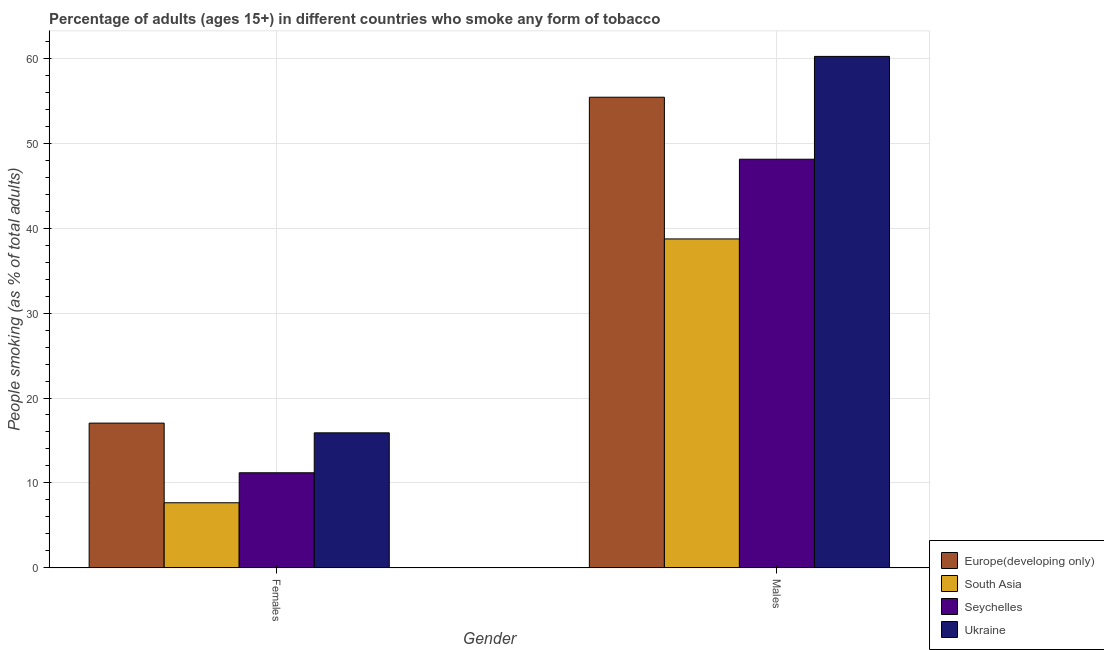How many different coloured bars are there?
Offer a very short reply. 4. How many bars are there on the 2nd tick from the right?
Your response must be concise. 4. What is the label of the 2nd group of bars from the left?
Ensure brevity in your answer.  Males. What is the percentage of females who smoke in Europe(developing only)?
Provide a succinct answer. 17.04. Across all countries, what is the maximum percentage of males who smoke?
Offer a terse response. 60.2. Across all countries, what is the minimum percentage of females who smoke?
Your response must be concise. 7.67. In which country was the percentage of females who smoke maximum?
Your answer should be compact. Europe(developing only). What is the total percentage of males who smoke in the graph?
Offer a terse response. 202.42. What is the difference between the percentage of males who smoke in South Asia and that in Ukraine?
Make the answer very short. -21.48. What is the difference between the percentage of females who smoke in Ukraine and the percentage of males who smoke in South Asia?
Offer a terse response. -22.82. What is the average percentage of males who smoke per country?
Your answer should be compact. 50.6. What is the difference between the percentage of females who smoke and percentage of males who smoke in Seychelles?
Your answer should be very brief. -36.9. What is the ratio of the percentage of males who smoke in Europe(developing only) to that in Ukraine?
Make the answer very short. 0.92. Is the percentage of males who smoke in Europe(developing only) less than that in Ukraine?
Your answer should be compact. Yes. What does the 2nd bar from the left in Females represents?
Give a very brief answer. South Asia. What does the 3rd bar from the right in Males represents?
Make the answer very short. South Asia. Are the values on the major ticks of Y-axis written in scientific E-notation?
Provide a short and direct response. No. Does the graph contain any zero values?
Your response must be concise. No. Does the graph contain grids?
Your answer should be compact. Yes. How are the legend labels stacked?
Provide a succinct answer. Vertical. What is the title of the graph?
Provide a succinct answer. Percentage of adults (ages 15+) in different countries who smoke any form of tobacco. What is the label or title of the Y-axis?
Your response must be concise. People smoking (as % of total adults). What is the People smoking (as % of total adults) of Europe(developing only) in Females?
Offer a terse response. 17.04. What is the People smoking (as % of total adults) of South Asia in Females?
Keep it short and to the point. 7.67. What is the People smoking (as % of total adults) of Seychelles in Females?
Make the answer very short. 11.2. What is the People smoking (as % of total adults) in Europe(developing only) in Males?
Provide a succinct answer. 55.4. What is the People smoking (as % of total adults) of South Asia in Males?
Your response must be concise. 38.72. What is the People smoking (as % of total adults) of Seychelles in Males?
Your answer should be compact. 48.1. What is the People smoking (as % of total adults) of Ukraine in Males?
Your response must be concise. 60.2. Across all Gender, what is the maximum People smoking (as % of total adults) in Europe(developing only)?
Your response must be concise. 55.4. Across all Gender, what is the maximum People smoking (as % of total adults) in South Asia?
Offer a terse response. 38.72. Across all Gender, what is the maximum People smoking (as % of total adults) in Seychelles?
Ensure brevity in your answer.  48.1. Across all Gender, what is the maximum People smoking (as % of total adults) in Ukraine?
Offer a very short reply. 60.2. Across all Gender, what is the minimum People smoking (as % of total adults) in Europe(developing only)?
Provide a succinct answer. 17.04. Across all Gender, what is the minimum People smoking (as % of total adults) in South Asia?
Offer a very short reply. 7.67. Across all Gender, what is the minimum People smoking (as % of total adults) of Ukraine?
Provide a short and direct response. 15.9. What is the total People smoking (as % of total adults) of Europe(developing only) in the graph?
Provide a short and direct response. 72.44. What is the total People smoking (as % of total adults) in South Asia in the graph?
Ensure brevity in your answer.  46.39. What is the total People smoking (as % of total adults) of Seychelles in the graph?
Your answer should be compact. 59.3. What is the total People smoking (as % of total adults) in Ukraine in the graph?
Make the answer very short. 76.1. What is the difference between the People smoking (as % of total adults) of Europe(developing only) in Females and that in Males?
Your response must be concise. -38.35. What is the difference between the People smoking (as % of total adults) of South Asia in Females and that in Males?
Your answer should be very brief. -31.05. What is the difference between the People smoking (as % of total adults) of Seychelles in Females and that in Males?
Ensure brevity in your answer.  -36.9. What is the difference between the People smoking (as % of total adults) of Ukraine in Females and that in Males?
Ensure brevity in your answer.  -44.3. What is the difference between the People smoking (as % of total adults) in Europe(developing only) in Females and the People smoking (as % of total adults) in South Asia in Males?
Your response must be concise. -21.68. What is the difference between the People smoking (as % of total adults) in Europe(developing only) in Females and the People smoking (as % of total adults) in Seychelles in Males?
Provide a short and direct response. -31.06. What is the difference between the People smoking (as % of total adults) in Europe(developing only) in Females and the People smoking (as % of total adults) in Ukraine in Males?
Provide a short and direct response. -43.16. What is the difference between the People smoking (as % of total adults) in South Asia in Females and the People smoking (as % of total adults) in Seychelles in Males?
Ensure brevity in your answer.  -40.43. What is the difference between the People smoking (as % of total adults) of South Asia in Females and the People smoking (as % of total adults) of Ukraine in Males?
Keep it short and to the point. -52.53. What is the difference between the People smoking (as % of total adults) of Seychelles in Females and the People smoking (as % of total adults) of Ukraine in Males?
Provide a short and direct response. -49. What is the average People smoking (as % of total adults) of Europe(developing only) per Gender?
Provide a short and direct response. 36.22. What is the average People smoking (as % of total adults) of South Asia per Gender?
Your answer should be very brief. 23.2. What is the average People smoking (as % of total adults) of Seychelles per Gender?
Provide a short and direct response. 29.65. What is the average People smoking (as % of total adults) in Ukraine per Gender?
Your response must be concise. 38.05. What is the difference between the People smoking (as % of total adults) of Europe(developing only) and People smoking (as % of total adults) of South Asia in Females?
Keep it short and to the point. 9.37. What is the difference between the People smoking (as % of total adults) in Europe(developing only) and People smoking (as % of total adults) in Seychelles in Females?
Your answer should be compact. 5.84. What is the difference between the People smoking (as % of total adults) in Europe(developing only) and People smoking (as % of total adults) in Ukraine in Females?
Ensure brevity in your answer.  1.14. What is the difference between the People smoking (as % of total adults) in South Asia and People smoking (as % of total adults) in Seychelles in Females?
Provide a short and direct response. -3.53. What is the difference between the People smoking (as % of total adults) in South Asia and People smoking (as % of total adults) in Ukraine in Females?
Offer a terse response. -8.23. What is the difference between the People smoking (as % of total adults) of Europe(developing only) and People smoking (as % of total adults) of South Asia in Males?
Provide a succinct answer. 16.67. What is the difference between the People smoking (as % of total adults) of Europe(developing only) and People smoking (as % of total adults) of Seychelles in Males?
Give a very brief answer. 7.3. What is the difference between the People smoking (as % of total adults) in Europe(developing only) and People smoking (as % of total adults) in Ukraine in Males?
Your answer should be compact. -4.8. What is the difference between the People smoking (as % of total adults) in South Asia and People smoking (as % of total adults) in Seychelles in Males?
Provide a short and direct response. -9.38. What is the difference between the People smoking (as % of total adults) in South Asia and People smoking (as % of total adults) in Ukraine in Males?
Your response must be concise. -21.48. What is the difference between the People smoking (as % of total adults) of Seychelles and People smoking (as % of total adults) of Ukraine in Males?
Offer a terse response. -12.1. What is the ratio of the People smoking (as % of total adults) of Europe(developing only) in Females to that in Males?
Provide a short and direct response. 0.31. What is the ratio of the People smoking (as % of total adults) in South Asia in Females to that in Males?
Offer a very short reply. 0.2. What is the ratio of the People smoking (as % of total adults) of Seychelles in Females to that in Males?
Your answer should be compact. 0.23. What is the ratio of the People smoking (as % of total adults) of Ukraine in Females to that in Males?
Ensure brevity in your answer.  0.26. What is the difference between the highest and the second highest People smoking (as % of total adults) in Europe(developing only)?
Offer a terse response. 38.35. What is the difference between the highest and the second highest People smoking (as % of total adults) of South Asia?
Keep it short and to the point. 31.05. What is the difference between the highest and the second highest People smoking (as % of total adults) of Seychelles?
Provide a succinct answer. 36.9. What is the difference between the highest and the second highest People smoking (as % of total adults) of Ukraine?
Keep it short and to the point. 44.3. What is the difference between the highest and the lowest People smoking (as % of total adults) of Europe(developing only)?
Give a very brief answer. 38.35. What is the difference between the highest and the lowest People smoking (as % of total adults) of South Asia?
Offer a terse response. 31.05. What is the difference between the highest and the lowest People smoking (as % of total adults) of Seychelles?
Provide a succinct answer. 36.9. What is the difference between the highest and the lowest People smoking (as % of total adults) in Ukraine?
Your answer should be compact. 44.3. 